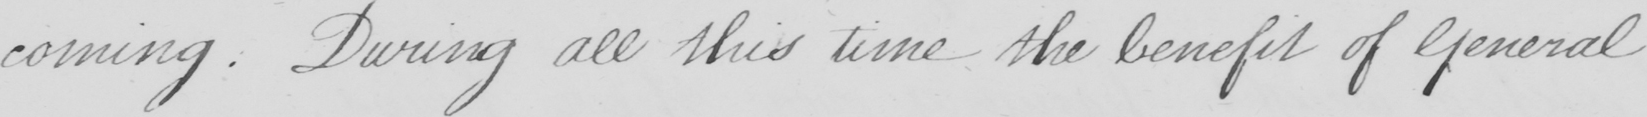What does this handwritten line say? -coming . During all this time the benefit of General 